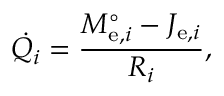Convert formula to latex. <formula><loc_0><loc_0><loc_500><loc_500>{ \dot { Q _ { i } } } = { \frac { M _ { e , i } ^ { \circ } - J _ { e , i } } { R _ { i } } } ,</formula> 